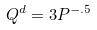Convert formula to latex. <formula><loc_0><loc_0><loc_500><loc_500>Q ^ { d } = 3 P ^ { - . 5 }</formula> 